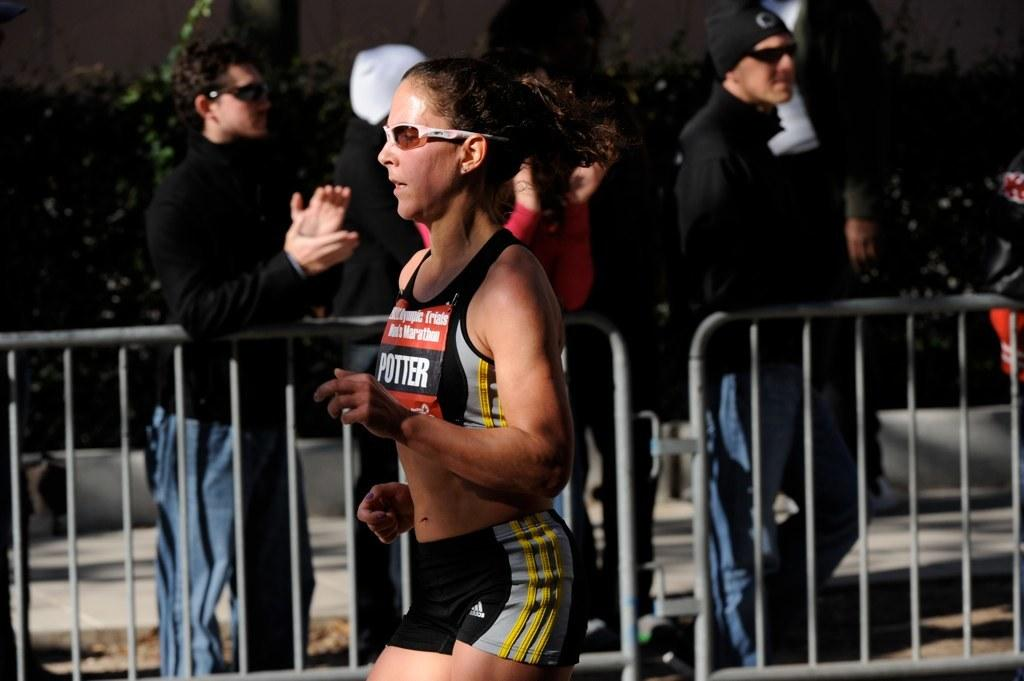Provide a one-sentence caption for the provided image. A runner with the name Potter is competing during an athletics event. 